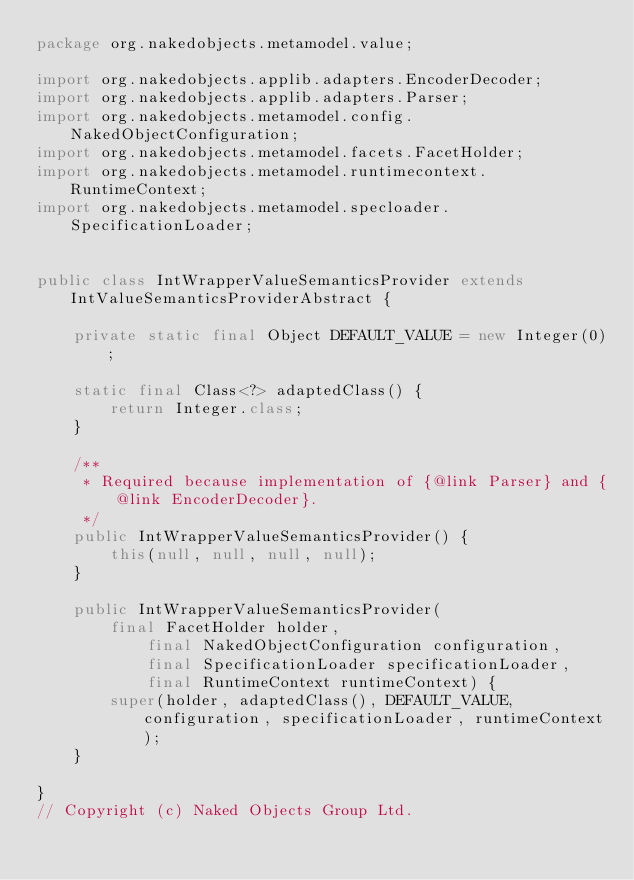<code> <loc_0><loc_0><loc_500><loc_500><_Java_>package org.nakedobjects.metamodel.value;

import org.nakedobjects.applib.adapters.EncoderDecoder;
import org.nakedobjects.applib.adapters.Parser;
import org.nakedobjects.metamodel.config.NakedObjectConfiguration;
import org.nakedobjects.metamodel.facets.FacetHolder;
import org.nakedobjects.metamodel.runtimecontext.RuntimeContext;
import org.nakedobjects.metamodel.specloader.SpecificationLoader;


public class IntWrapperValueSemanticsProvider extends IntValueSemanticsProviderAbstract {

    private static final Object DEFAULT_VALUE = new Integer(0);

    static final Class<?> adaptedClass() {
        return Integer.class;
    }

    /**
     * Required because implementation of {@link Parser} and {@link EncoderDecoder}.
     */
    public IntWrapperValueSemanticsProvider() {
        this(null, null, null, null);
    }

    public IntWrapperValueSemanticsProvider(
    		final FacetHolder holder,
            final NakedObjectConfiguration configuration, 
            final SpecificationLoader specificationLoader, 
            final RuntimeContext runtimeContext) {
        super(holder, adaptedClass(), DEFAULT_VALUE, configuration, specificationLoader, runtimeContext);
    }

}
// Copyright (c) Naked Objects Group Ltd.
</code> 